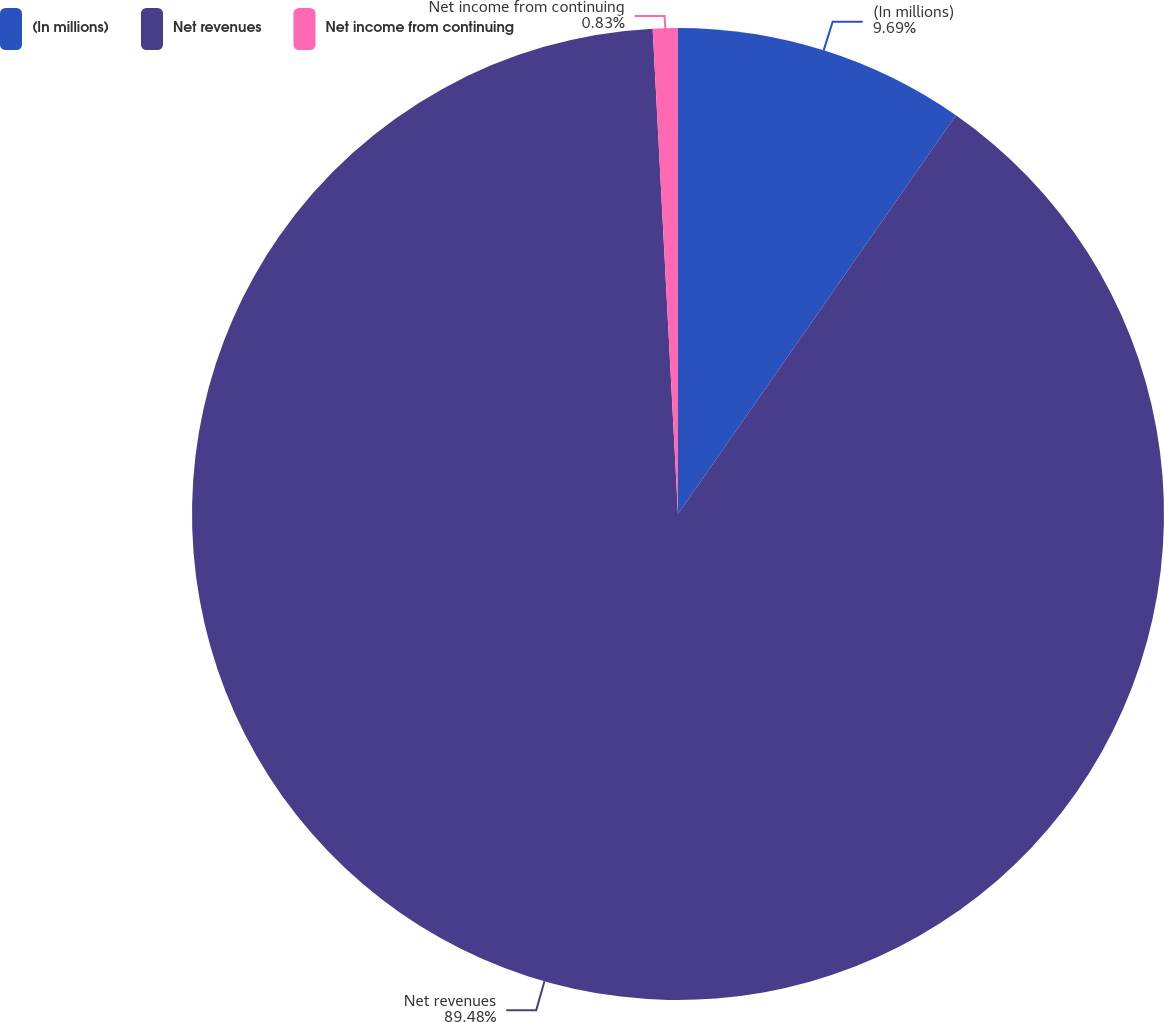<chart> <loc_0><loc_0><loc_500><loc_500><pie_chart><fcel>(In millions)<fcel>Net revenues<fcel>Net income from continuing<nl><fcel>9.69%<fcel>89.48%<fcel>0.83%<nl></chart> 